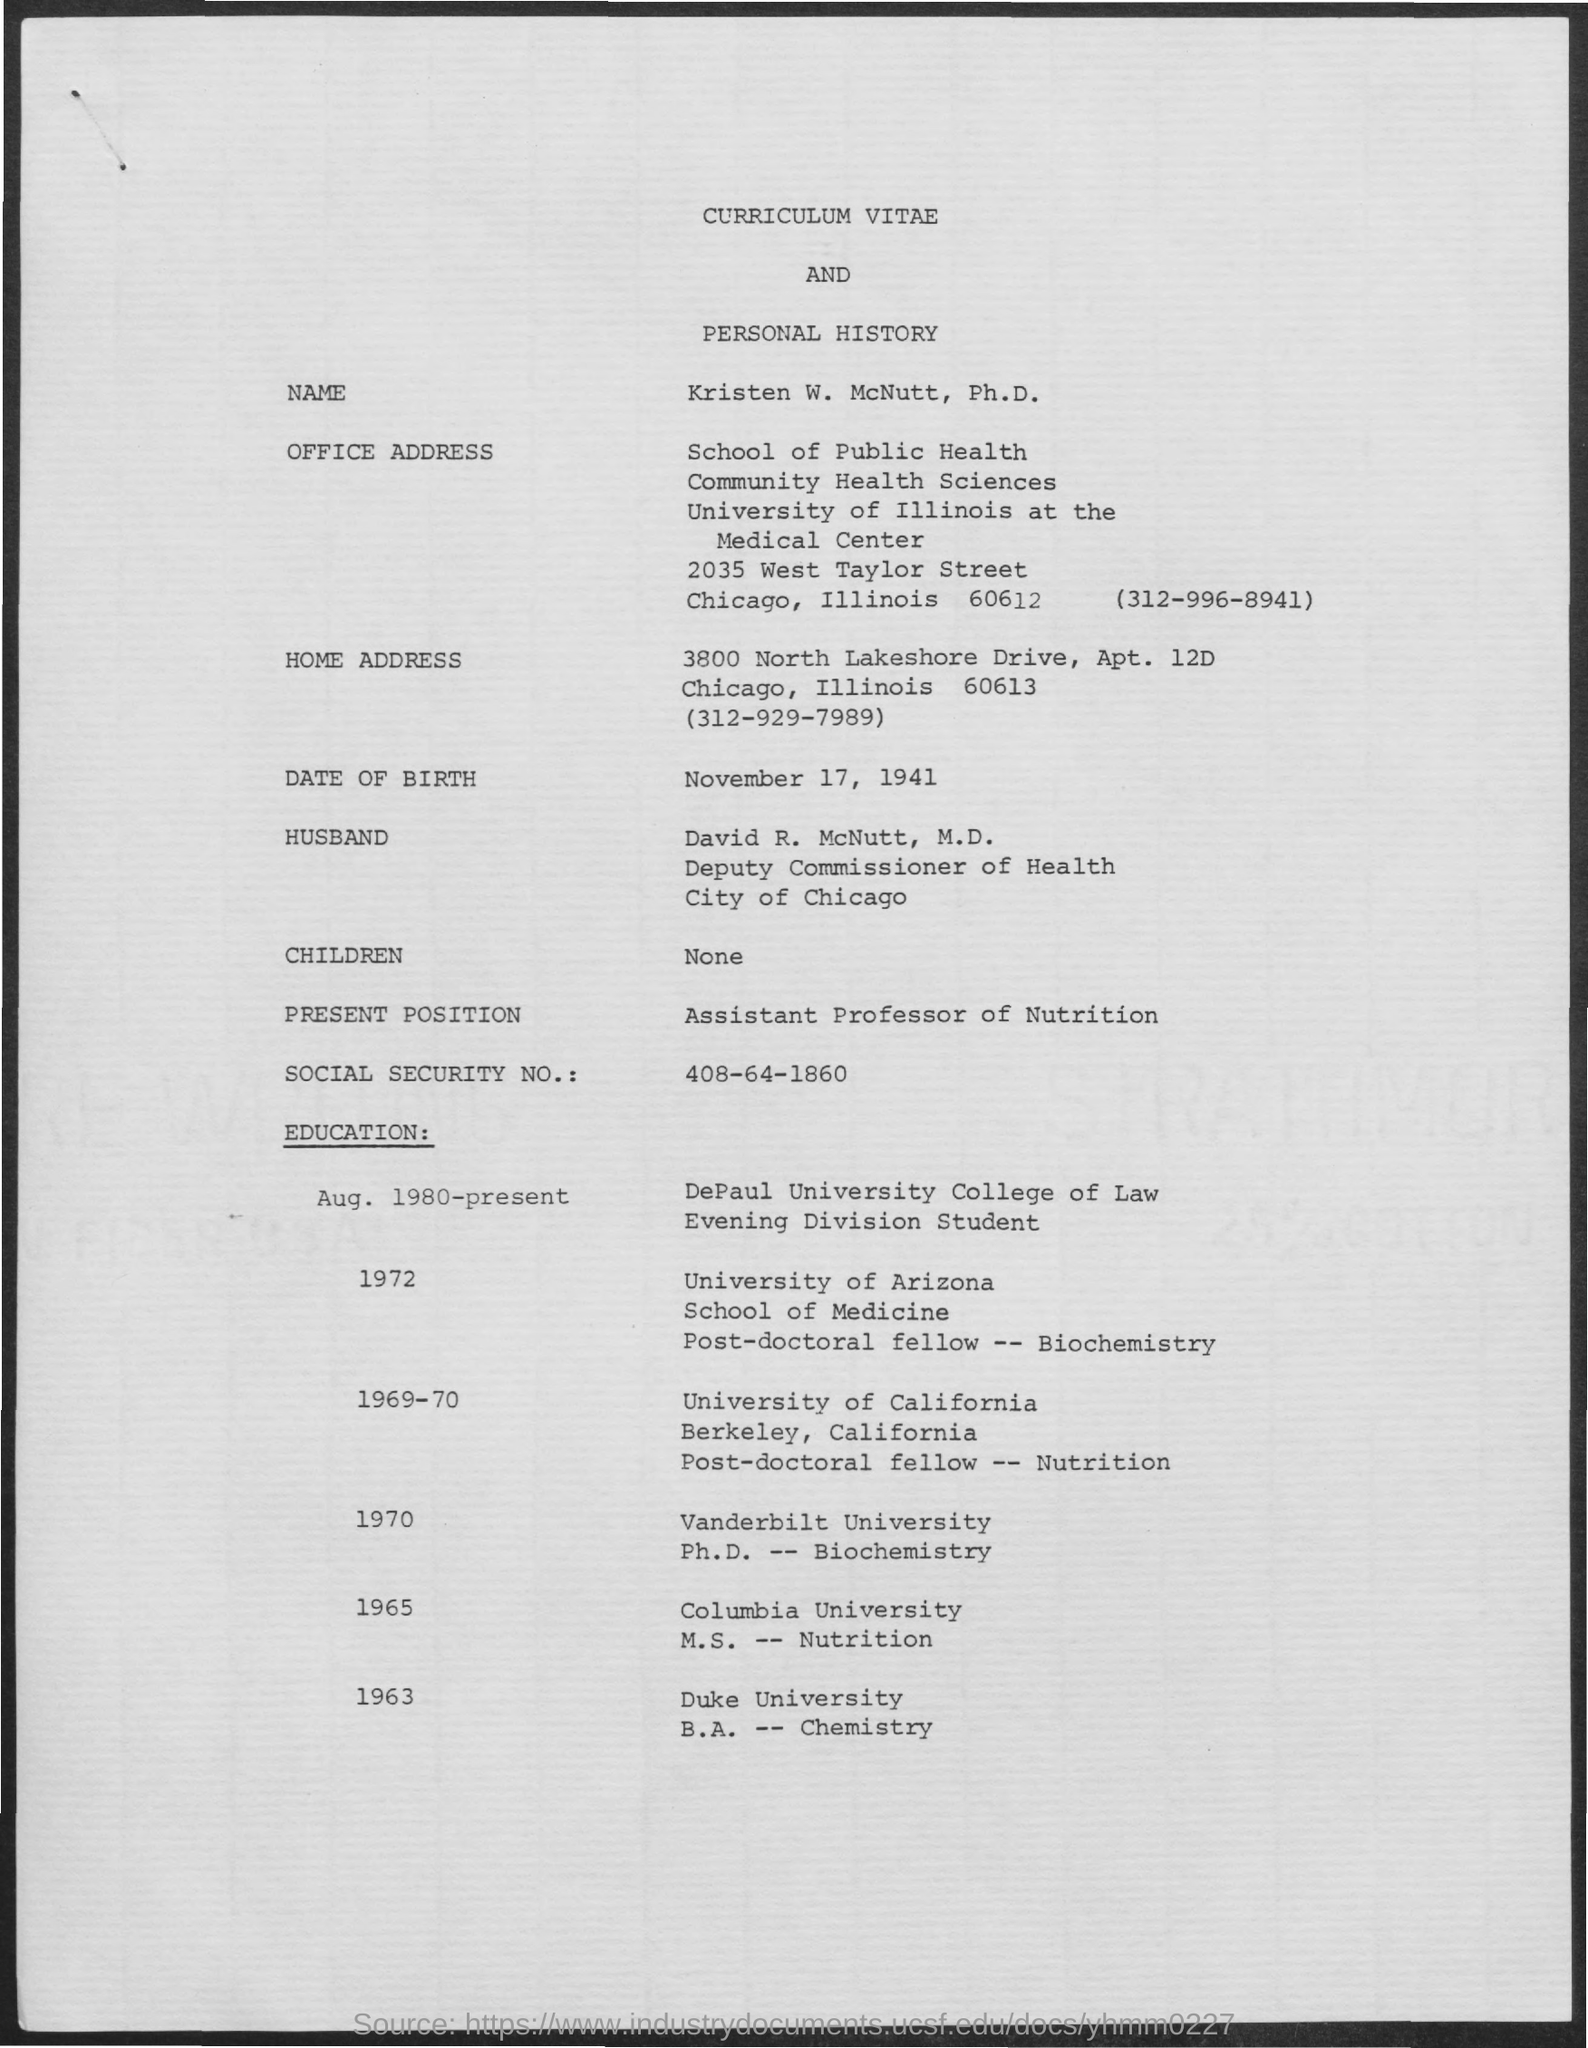Outline some significant characteristics in this image. The present position of the speaker is that of an Assistant Professor of Nutrition. The social security number is 408-64-1860. The date of birth of the individual is November 17, 1941. 